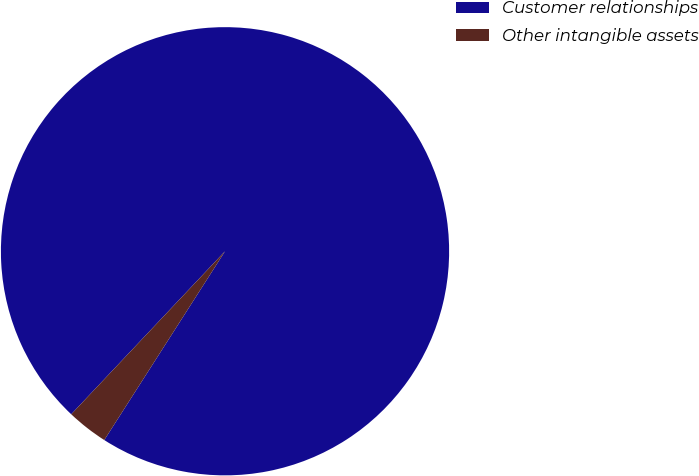Convert chart to OTSL. <chart><loc_0><loc_0><loc_500><loc_500><pie_chart><fcel>Customer relationships<fcel>Other intangible assets<nl><fcel>97.02%<fcel>2.98%<nl></chart> 